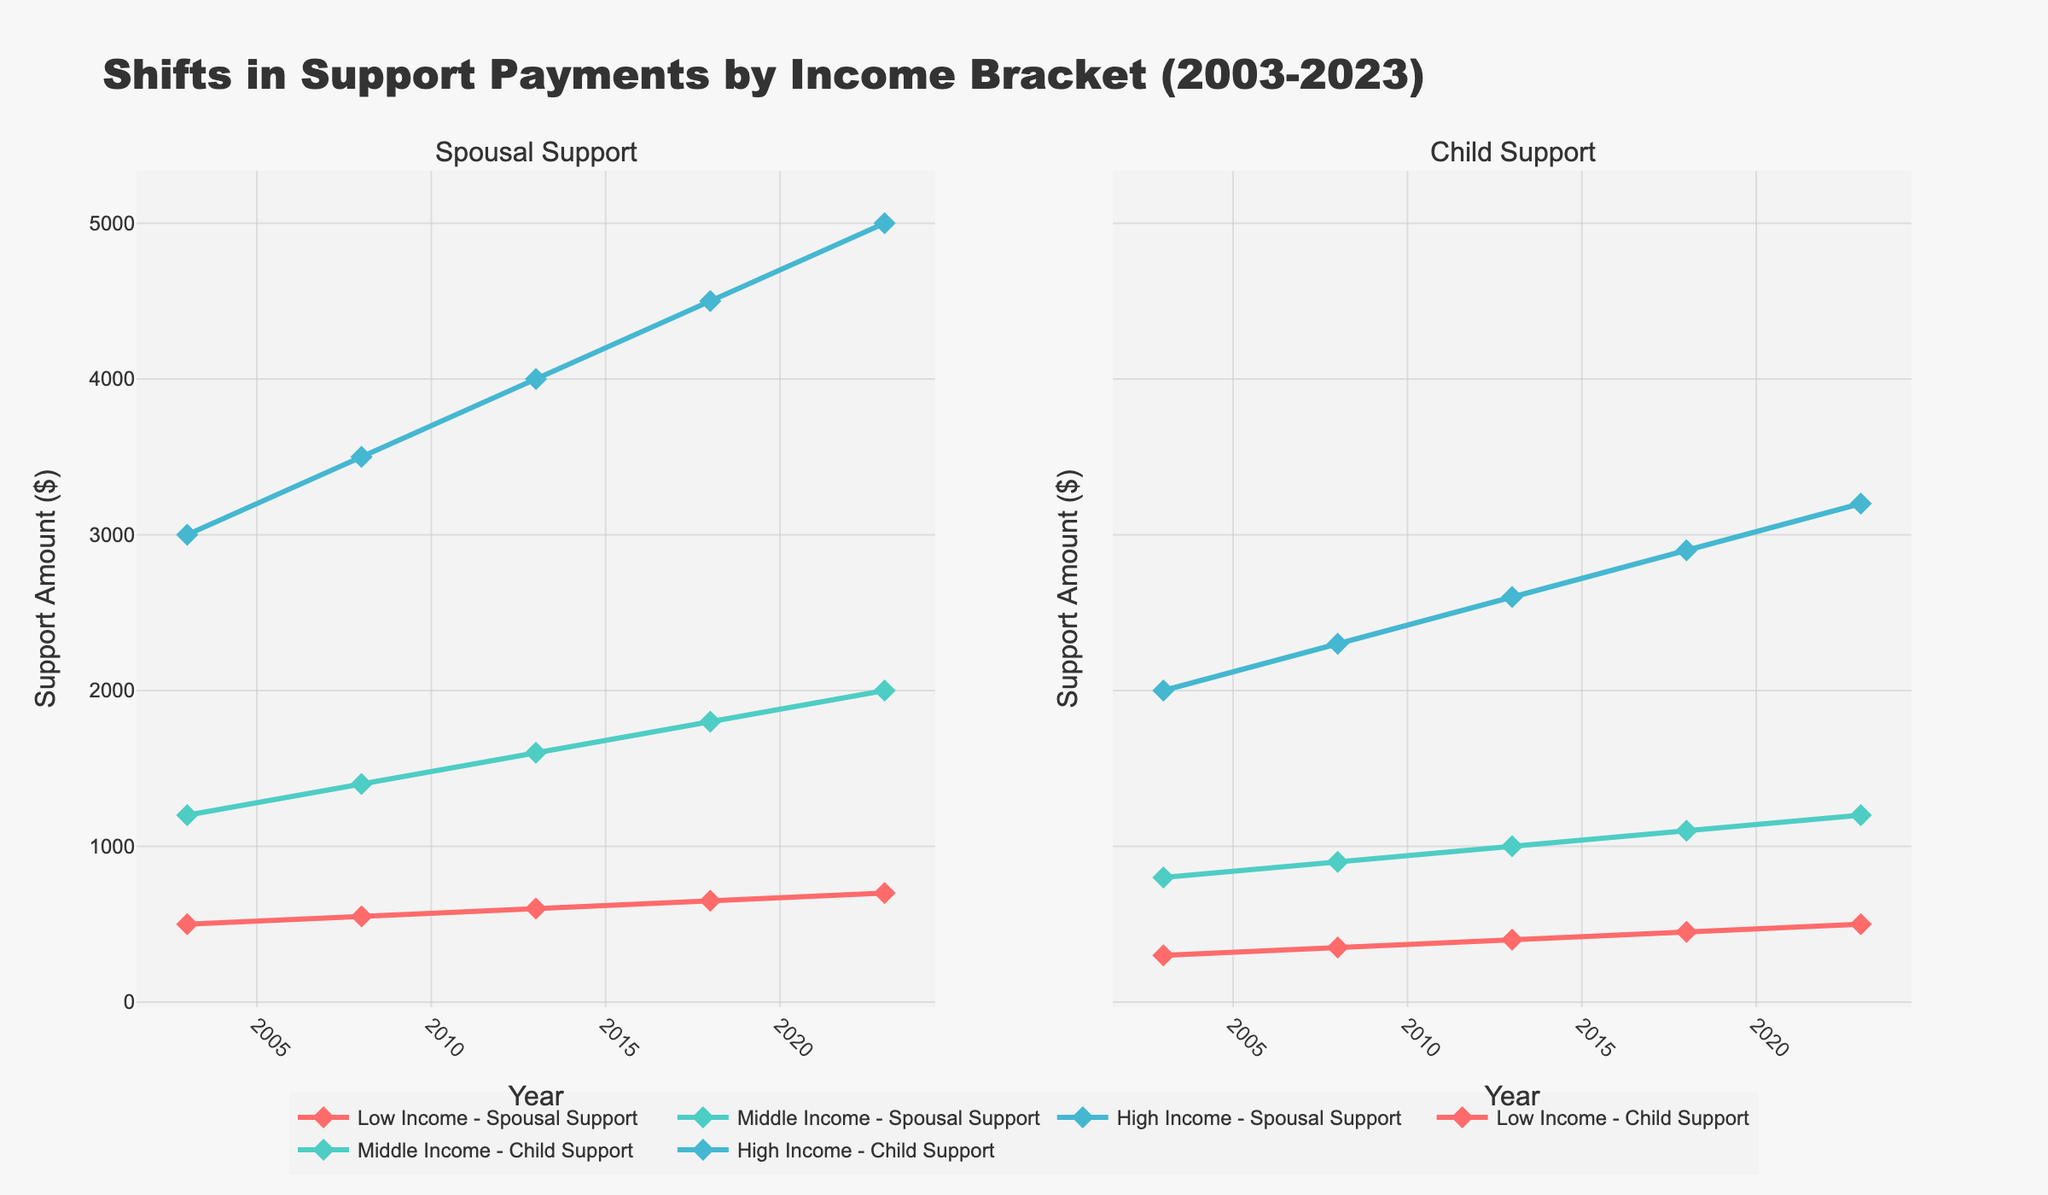what is the title of the figure? The title is located at the top and is written in large, bold text.
Answer: Shifts in Support Payments by Income Bracket (2003-2023) What is the general trend for spousal support over the 20 years? By observing the trend lines for spousal support in the left subplot, we can see that all income brackets show a steady increase in spousal support amounts from 2003 to 2023.
Answer: Steadily increasing how many income brackets are there? The different income brackets can be identified by examining the legend or the different labeled lines in the subplot.
Answer: Three In what year did middle-income spousal support reach $1600? We can trace back the middle-income spousal support line to the year when it reached the $1600 mark.
Answer: 2013 How much was the child support for low-income bracket in 2023? We locate the line for low-income child support in the right subplot and find the value at 2023.
Answer: $500 Which income bracket saw the greatest increase in spousal support payments over the past 20 years? We check the starting and ending values of spousal support lines for each income bracket and determine which has the largest difference.
Answer: High Income What was the child support amount for high-income bracket in 2008? We look at the right subplot and trace the high-income child support line to the year 2008.
Answer: $2300 How does the spousal support amount for middle-income in 2023 compare to 2013? We check the spousal support levels for middle-income in both years in the left subplot and calculate the difference.
Answer: Higher by $400 What income bracket has the sharpest increase in child support from 2003 to 2023? By analyzing the child support lines' slopes in the right subplot, we identify which one has the steepest incline.
Answer: High Income What is the average spousal support amount for the low-income bracket across all years? By adding all the spousal support amounts for the low-income bracket and dividing by the number of years, we find the average.
Answer: $600 